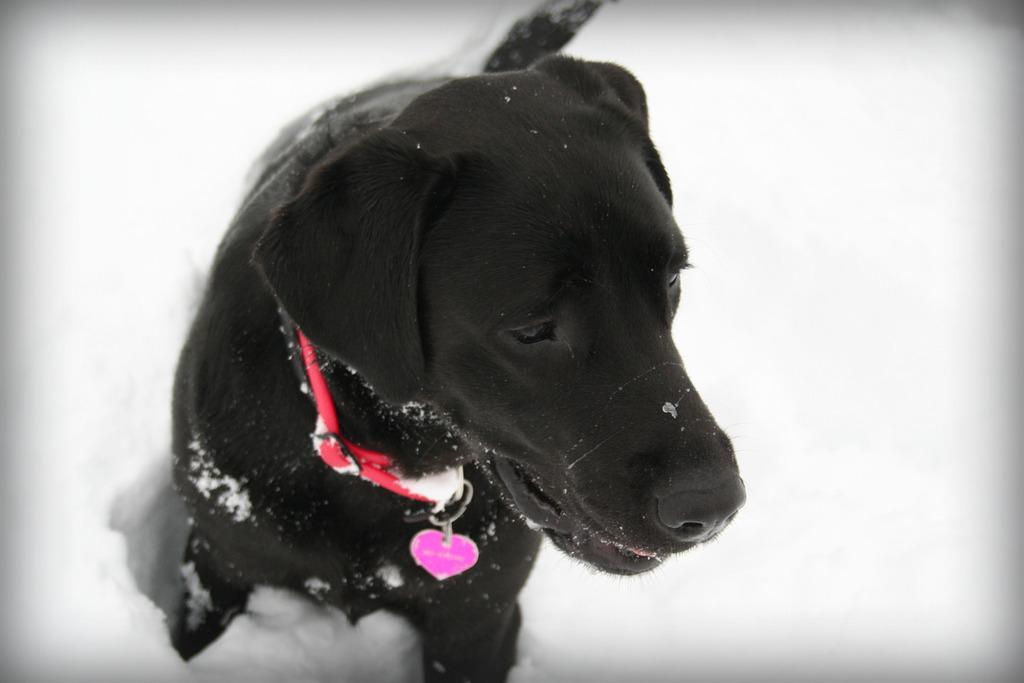In one or two sentences, can you explain what this image depicts? In this image we can see a black color dog. At the bottom of the image there is snow. 